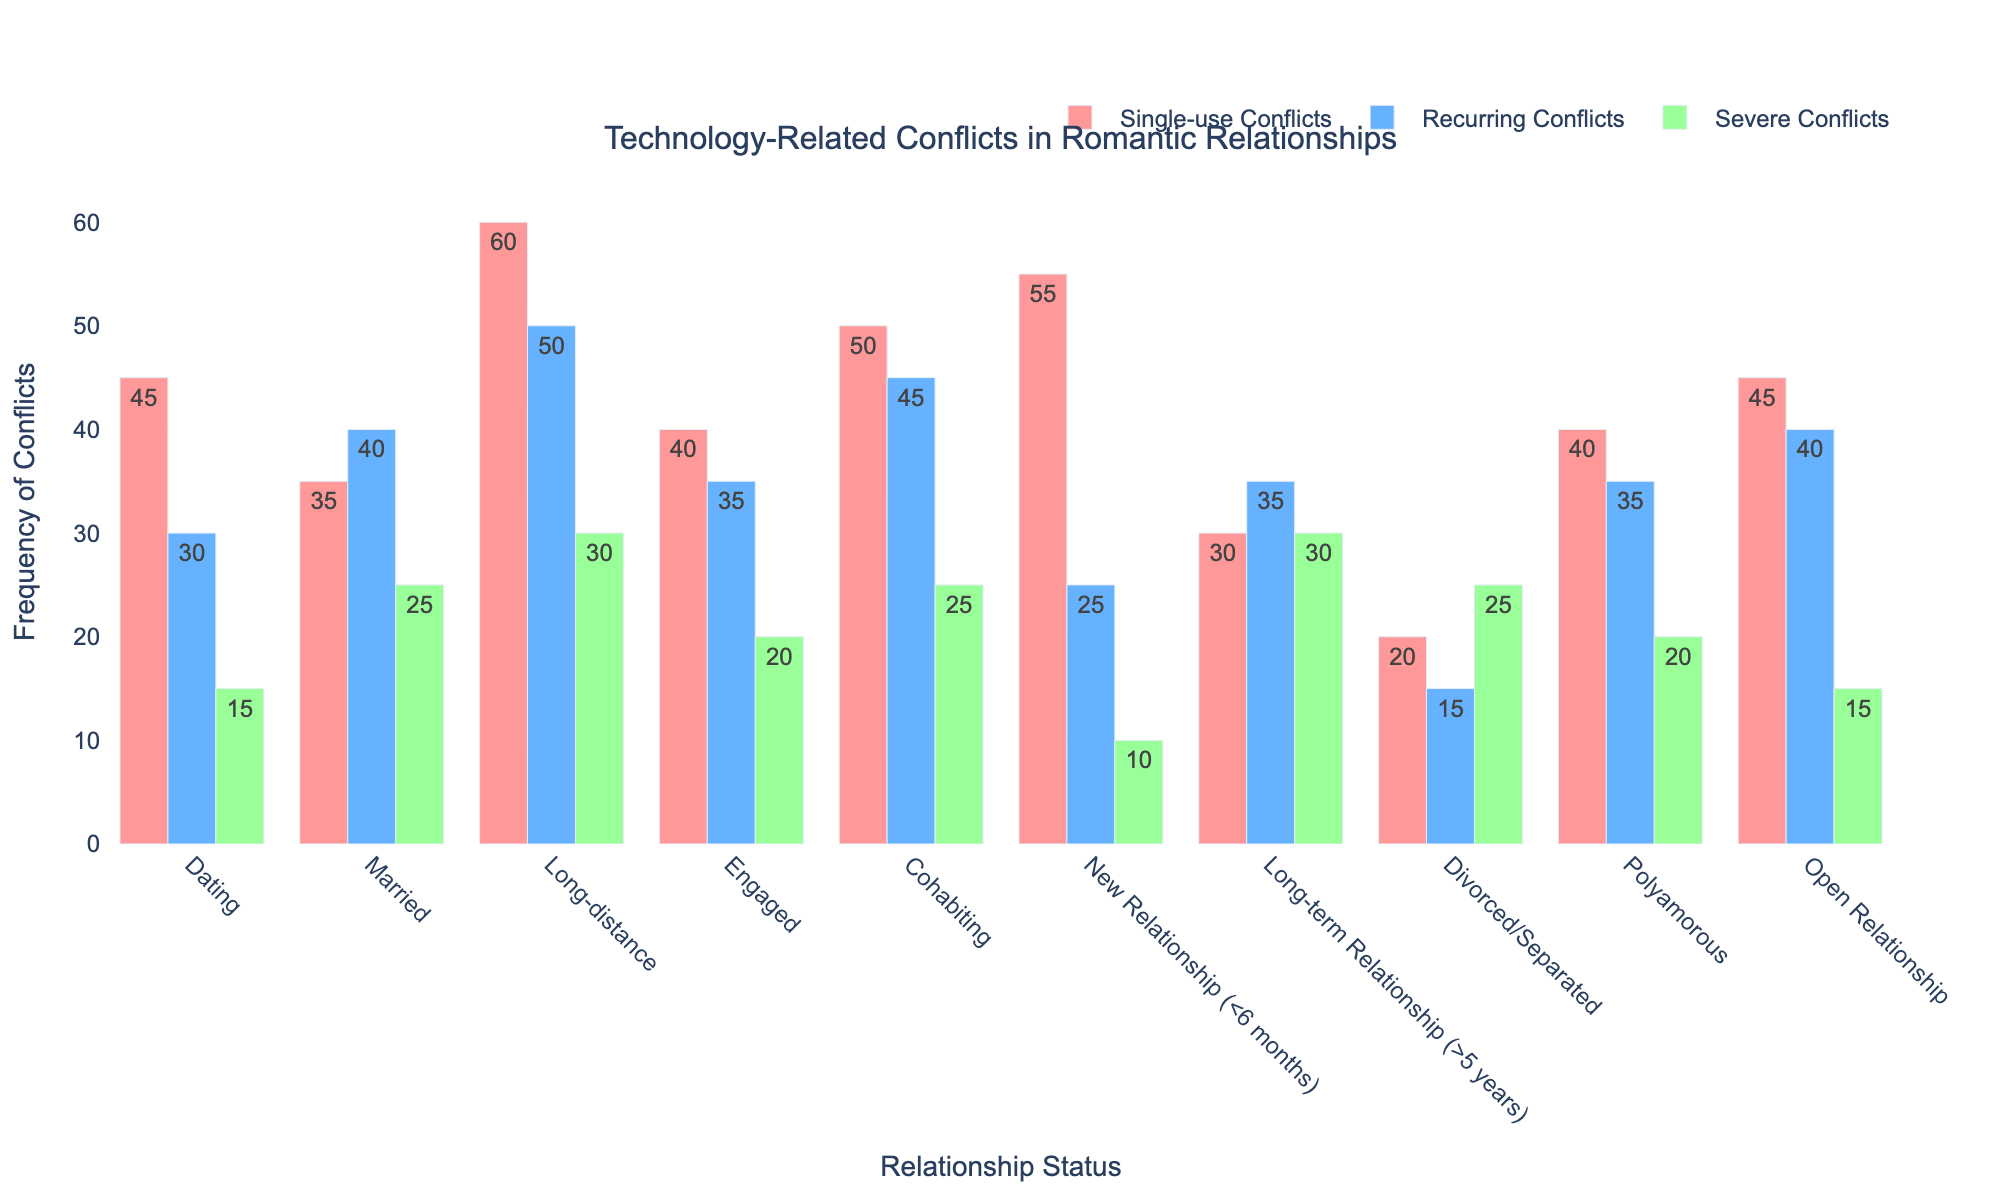What relationship status experiences the highest frequency of Single-use Conflicts? Locate the highest bar in the Single-use Conflicts category. The tallest bar is for Long-distance relationships, which has a value of 60.
Answer: Long-distance Between Married and Cohabiting, which has more Recurring Conflicts? Compare the height of the Recurring Conflicts bars for both Married and Cohabiting. Cohabiting has 45, while Married has 40.
Answer: Cohabiting How many total Severe Conflicts are reported by Divorced/Separated and Engaged relationships? Find the Severe Conflicts values for both Divorced/Separated (25) and Engaged (20), then sum them: 25 + 20 = 45.
Answer: 45 Which relationship statuses have the same frequency of Severe Conflicts? Identify relationship statuses with identical Severe Conflicts bar heights. Both Cohabiting and Married have 25 Severe Conflicts.
Answer: Married and Cohabiting What is the average frequency of Recurring Conflicts across all relationship statuses? Add the frequencies of Recurring Conflicts (30 + 40 + 50 + 35 + 45 + 25 + 35 + 15 + 35 + 40 = 350) and divide by the number of statuses (10): 350 / 10 = 35.
Answer: 35 Between New Relationship and Long-term Relationship, which one experiences fewer total conflicts (sum of all conflict types)? Calculate total conflicts for both: New Relationship (55+25+10=90) and Long-term (30+35+30=95). New Relationship has fewer total conflicts.
Answer: New Relationship What is the difference in Severe Conflicts between Engaged and Polyamorous relationships? Subtract the Severe Conflicts value of Engaged (20) from Polyamorous (20): 20 - 20 = 0.
Answer: 0 Which relationship statuses have more Single-use Conflicts than Severe Conflicts? Compare Single-use and Severe Conflicts values for each category. Dating, Married, Long-distance, Engaged, Cohabiting, New Relationship, Open Relationship meet the criteria.
Answer: Dating, Married, Long-distance, Engaged, Cohabiting, New Relationship, Open Relationship 